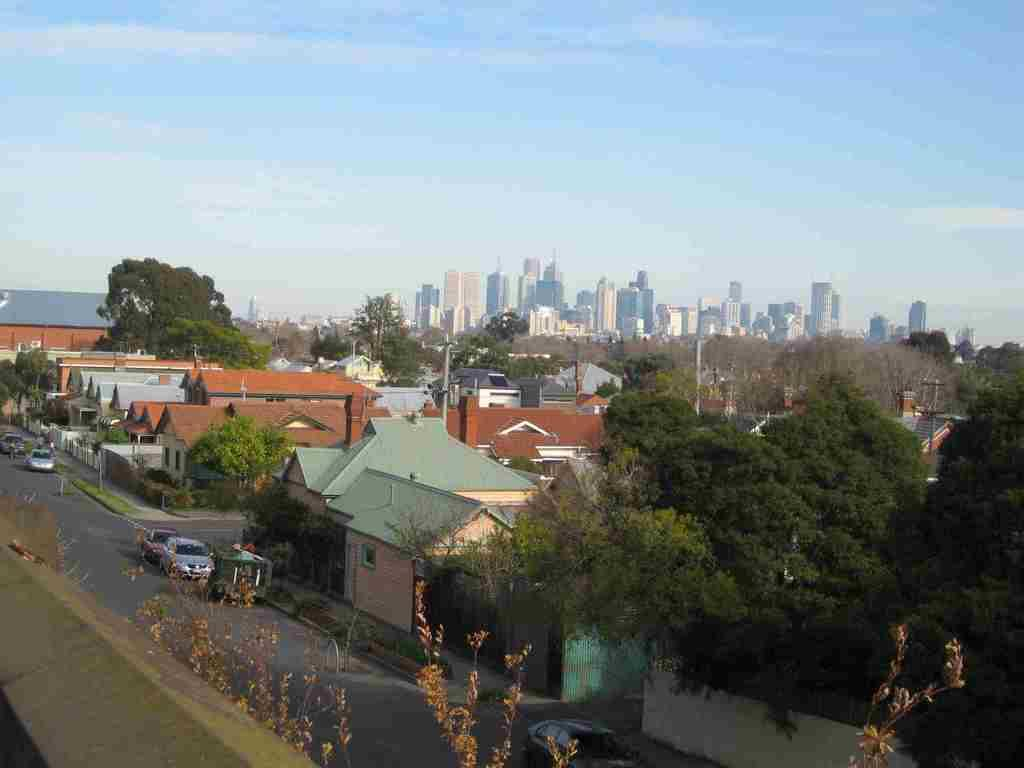What is the main feature in the center of the image? There is a road in the center of the image. What is happening on the road? Cars are present on the road. What type of structures can be seen in the image? There are buildings and sheds in the image. What type of vegetation is visible in the image? Trees are visible in the image. What else can be seen in the background of the image? There are poles and the sky visible in the background of the image. What type of error can be seen in the image? There is no error present in the image. What type of guitar can be seen in the image? There is no guitar present in the image. 